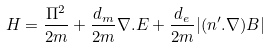<formula> <loc_0><loc_0><loc_500><loc_500>H = \frac { { \Pi } ^ { 2 } } { 2 m } + \frac { d _ { m } } { 2 m } { \nabla } . { E } + \frac { d _ { e } } { 2 m } | ( n ^ { \prime } . \nabla ) { B } |</formula> 